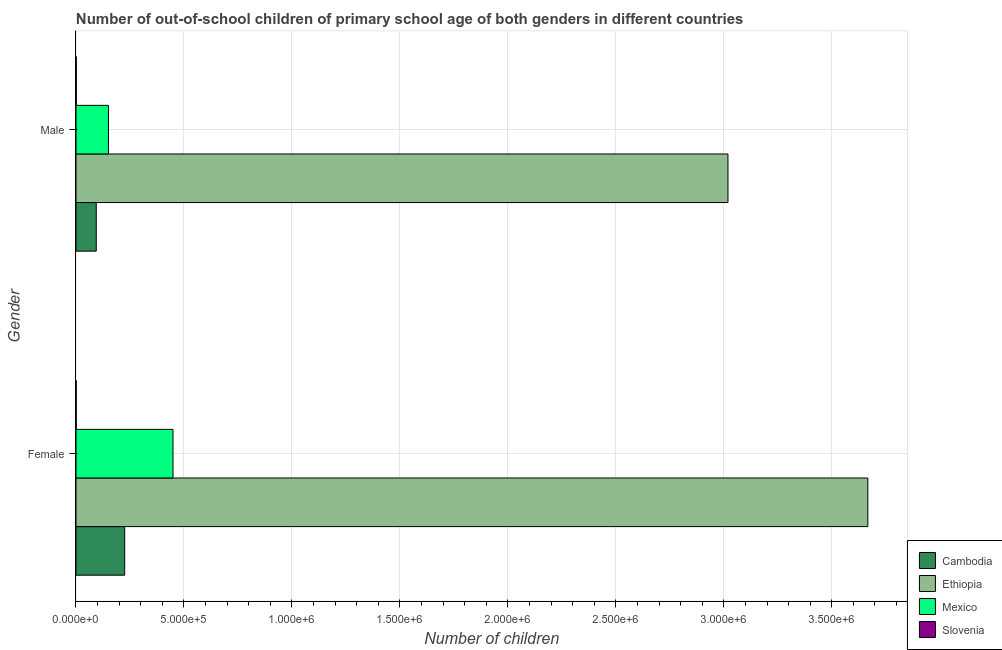Are the number of bars per tick equal to the number of legend labels?
Keep it short and to the point. Yes. Are the number of bars on each tick of the Y-axis equal?
Provide a short and direct response. Yes. How many bars are there on the 2nd tick from the top?
Provide a short and direct response. 4. How many bars are there on the 1st tick from the bottom?
Provide a short and direct response. 4. What is the number of male out-of-school students in Slovenia?
Offer a very short reply. 1356. Across all countries, what is the maximum number of female out-of-school students?
Give a very brief answer. 3.67e+06. Across all countries, what is the minimum number of female out-of-school students?
Your answer should be very brief. 1149. In which country was the number of female out-of-school students maximum?
Your answer should be very brief. Ethiopia. In which country was the number of female out-of-school students minimum?
Your answer should be compact. Slovenia. What is the total number of female out-of-school students in the graph?
Your response must be concise. 4.34e+06. What is the difference between the number of female out-of-school students in Mexico and that in Cambodia?
Give a very brief answer. 2.24e+05. What is the difference between the number of male out-of-school students in Cambodia and the number of female out-of-school students in Mexico?
Give a very brief answer. -3.55e+05. What is the average number of male out-of-school students per country?
Provide a succinct answer. 8.16e+05. What is the difference between the number of female out-of-school students and number of male out-of-school students in Mexico?
Your answer should be compact. 2.99e+05. What is the ratio of the number of male out-of-school students in Ethiopia to that in Slovenia?
Your answer should be compact. 2226.61. What does the 4th bar from the bottom in Male represents?
Provide a succinct answer. Slovenia. Are all the bars in the graph horizontal?
Give a very brief answer. Yes. Are the values on the major ticks of X-axis written in scientific E-notation?
Provide a succinct answer. Yes. Does the graph contain any zero values?
Give a very brief answer. No. Does the graph contain grids?
Give a very brief answer. Yes. Where does the legend appear in the graph?
Offer a terse response. Bottom right. What is the title of the graph?
Provide a succinct answer. Number of out-of-school children of primary school age of both genders in different countries. What is the label or title of the X-axis?
Your response must be concise. Number of children. What is the label or title of the Y-axis?
Offer a terse response. Gender. What is the Number of children of Cambodia in Female?
Your response must be concise. 2.25e+05. What is the Number of children of Ethiopia in Female?
Give a very brief answer. 3.67e+06. What is the Number of children in Mexico in Female?
Your response must be concise. 4.49e+05. What is the Number of children in Slovenia in Female?
Offer a terse response. 1149. What is the Number of children of Cambodia in Male?
Provide a short and direct response. 9.39e+04. What is the Number of children of Ethiopia in Male?
Your answer should be compact. 3.02e+06. What is the Number of children in Mexico in Male?
Offer a very short reply. 1.50e+05. What is the Number of children of Slovenia in Male?
Keep it short and to the point. 1356. Across all Gender, what is the maximum Number of children of Cambodia?
Your answer should be compact. 2.25e+05. Across all Gender, what is the maximum Number of children of Ethiopia?
Provide a short and direct response. 3.67e+06. Across all Gender, what is the maximum Number of children in Mexico?
Make the answer very short. 4.49e+05. Across all Gender, what is the maximum Number of children of Slovenia?
Offer a terse response. 1356. Across all Gender, what is the minimum Number of children in Cambodia?
Your response must be concise. 9.39e+04. Across all Gender, what is the minimum Number of children in Ethiopia?
Keep it short and to the point. 3.02e+06. Across all Gender, what is the minimum Number of children in Mexico?
Ensure brevity in your answer.  1.50e+05. Across all Gender, what is the minimum Number of children of Slovenia?
Keep it short and to the point. 1149. What is the total Number of children in Cambodia in the graph?
Provide a succinct answer. 3.19e+05. What is the total Number of children in Ethiopia in the graph?
Provide a succinct answer. 6.69e+06. What is the total Number of children in Mexico in the graph?
Keep it short and to the point. 5.99e+05. What is the total Number of children of Slovenia in the graph?
Give a very brief answer. 2505. What is the difference between the Number of children of Cambodia in Female and that in Male?
Provide a succinct answer. 1.32e+05. What is the difference between the Number of children in Ethiopia in Female and that in Male?
Keep it short and to the point. 6.48e+05. What is the difference between the Number of children in Mexico in Female and that in Male?
Your answer should be compact. 2.99e+05. What is the difference between the Number of children of Slovenia in Female and that in Male?
Ensure brevity in your answer.  -207. What is the difference between the Number of children of Cambodia in Female and the Number of children of Ethiopia in Male?
Your response must be concise. -2.79e+06. What is the difference between the Number of children of Cambodia in Female and the Number of children of Mexico in Male?
Provide a succinct answer. 7.52e+04. What is the difference between the Number of children in Cambodia in Female and the Number of children in Slovenia in Male?
Offer a terse response. 2.24e+05. What is the difference between the Number of children in Ethiopia in Female and the Number of children in Mexico in Male?
Offer a terse response. 3.52e+06. What is the difference between the Number of children in Ethiopia in Female and the Number of children in Slovenia in Male?
Your answer should be compact. 3.67e+06. What is the difference between the Number of children of Mexico in Female and the Number of children of Slovenia in Male?
Keep it short and to the point. 4.48e+05. What is the average Number of children in Cambodia per Gender?
Your answer should be very brief. 1.60e+05. What is the average Number of children of Ethiopia per Gender?
Provide a succinct answer. 3.34e+06. What is the average Number of children of Mexico per Gender?
Provide a short and direct response. 3.00e+05. What is the average Number of children in Slovenia per Gender?
Offer a terse response. 1252.5. What is the difference between the Number of children in Cambodia and Number of children in Ethiopia in Female?
Provide a succinct answer. -3.44e+06. What is the difference between the Number of children of Cambodia and Number of children of Mexico in Female?
Your answer should be compact. -2.24e+05. What is the difference between the Number of children in Cambodia and Number of children in Slovenia in Female?
Keep it short and to the point. 2.24e+05. What is the difference between the Number of children of Ethiopia and Number of children of Mexico in Female?
Keep it short and to the point. 3.22e+06. What is the difference between the Number of children in Ethiopia and Number of children in Slovenia in Female?
Your response must be concise. 3.67e+06. What is the difference between the Number of children of Mexico and Number of children of Slovenia in Female?
Give a very brief answer. 4.48e+05. What is the difference between the Number of children in Cambodia and Number of children in Ethiopia in Male?
Provide a short and direct response. -2.93e+06. What is the difference between the Number of children in Cambodia and Number of children in Mexico in Male?
Keep it short and to the point. -5.63e+04. What is the difference between the Number of children in Cambodia and Number of children in Slovenia in Male?
Provide a succinct answer. 9.26e+04. What is the difference between the Number of children of Ethiopia and Number of children of Mexico in Male?
Provide a succinct answer. 2.87e+06. What is the difference between the Number of children of Ethiopia and Number of children of Slovenia in Male?
Provide a succinct answer. 3.02e+06. What is the difference between the Number of children of Mexico and Number of children of Slovenia in Male?
Your answer should be compact. 1.49e+05. What is the ratio of the Number of children of Cambodia in Female to that in Male?
Provide a short and direct response. 2.4. What is the ratio of the Number of children in Ethiopia in Female to that in Male?
Offer a terse response. 1.21. What is the ratio of the Number of children of Mexico in Female to that in Male?
Your answer should be compact. 2.99. What is the ratio of the Number of children in Slovenia in Female to that in Male?
Provide a short and direct response. 0.85. What is the difference between the highest and the second highest Number of children in Cambodia?
Provide a succinct answer. 1.32e+05. What is the difference between the highest and the second highest Number of children of Ethiopia?
Ensure brevity in your answer.  6.48e+05. What is the difference between the highest and the second highest Number of children of Mexico?
Keep it short and to the point. 2.99e+05. What is the difference between the highest and the second highest Number of children in Slovenia?
Your response must be concise. 207. What is the difference between the highest and the lowest Number of children in Cambodia?
Ensure brevity in your answer.  1.32e+05. What is the difference between the highest and the lowest Number of children in Ethiopia?
Give a very brief answer. 6.48e+05. What is the difference between the highest and the lowest Number of children of Mexico?
Keep it short and to the point. 2.99e+05. What is the difference between the highest and the lowest Number of children of Slovenia?
Offer a very short reply. 207. 